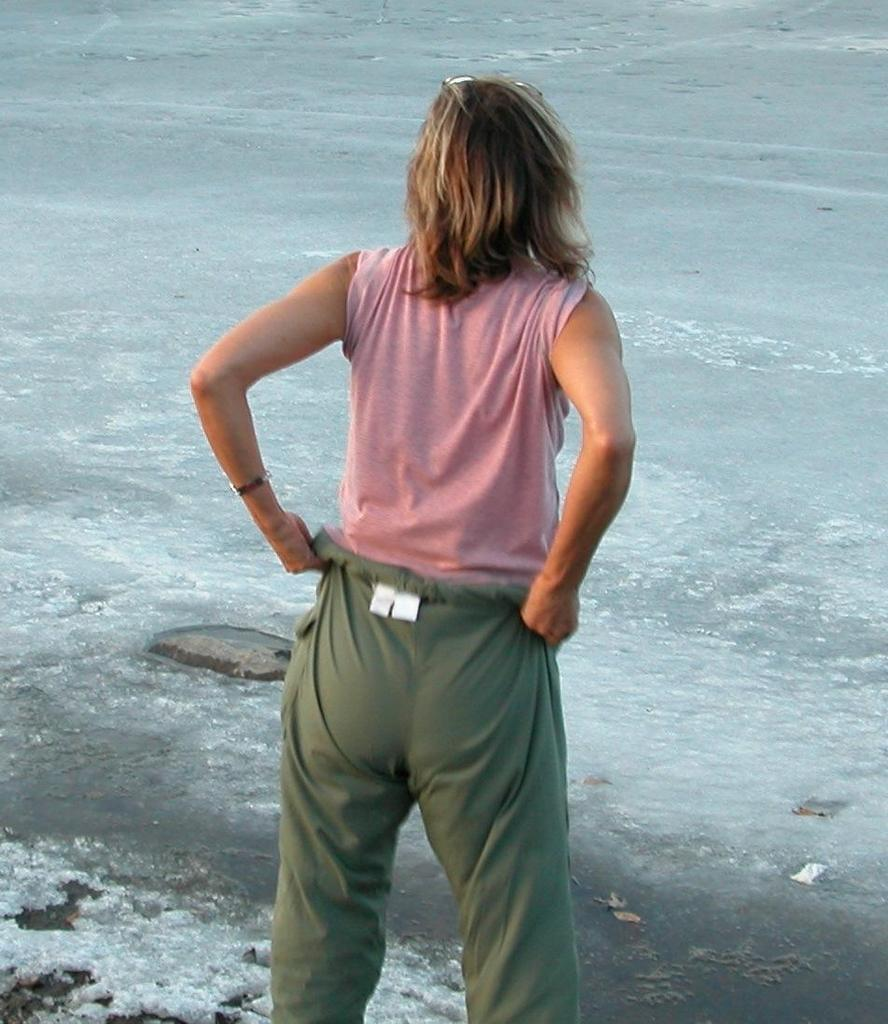What is the main subject of the image? There is a person standing in the image. What can be seen in the background or surrounding the person? There is water visible in the image. What type of key is being used to unlock the value in the image? There is no key or value present in the image; it features a person standing near water. 